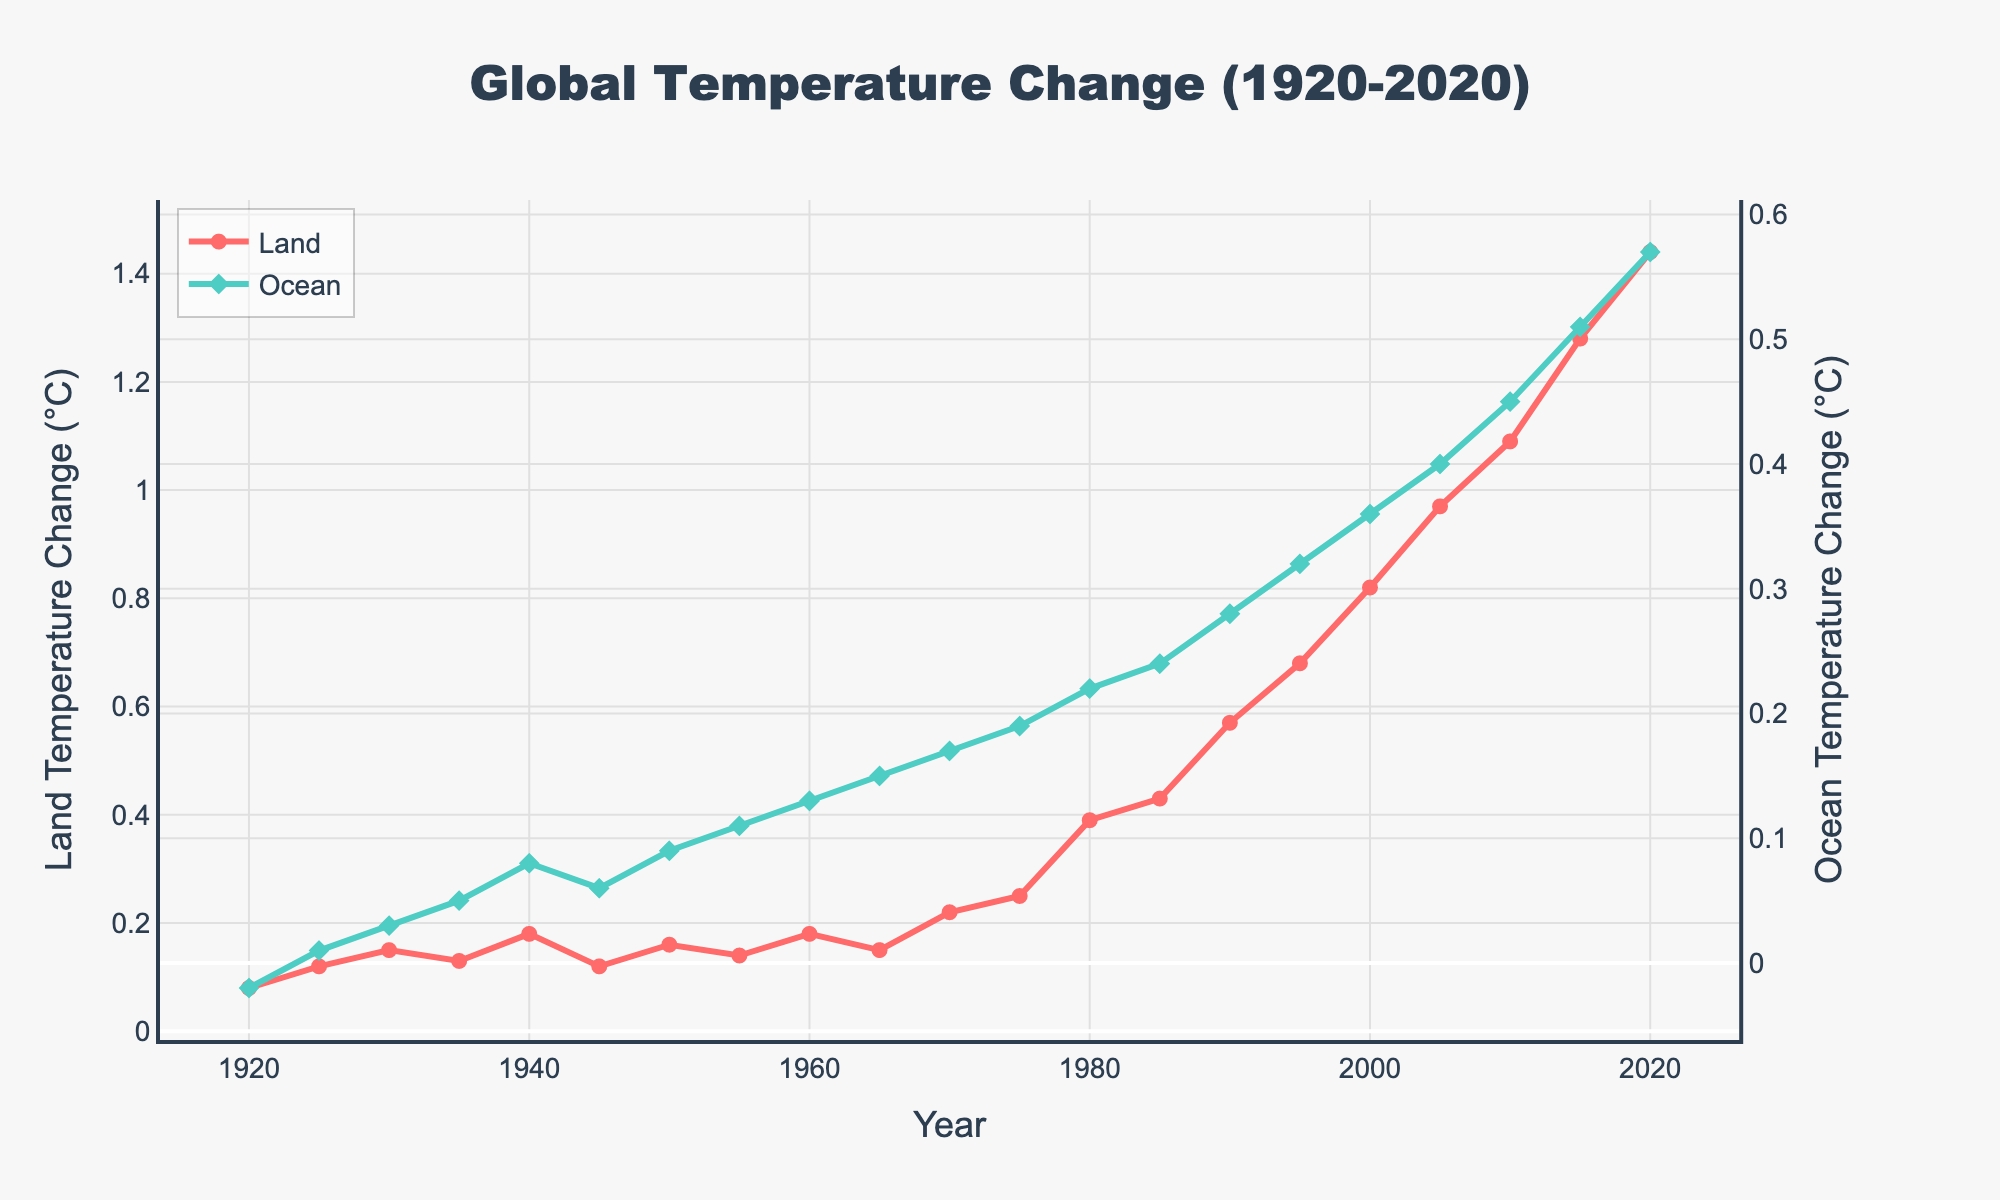What is the overall trend in land temperature change shown in the figure? The overall trend in the figure shows a clear increase in the land temperature change from 1920 to 2020. Reviewing the line graph, the land temperature change starts from 0.08°C in 1920 and reaches 1.44°C in 2020, indicating a steady rise.
Answer: Increasing How does the ocean temperature change in 1970 compare to that in 2020? The ocean temperature change in 1970 is 0.17°C, while it is 0.57°C in 2020. Comparing these values shows that the ocean temperature change has increased by 0.40°C over this period.
Answer: Increased By how much did the land temperature change between 1960 and 1980? In 1960, the land temperature change is 0.18°C, and by 1980, it is 0.39°C. The difference between these values is 0.39 - 0.18 = 0.21°C.
Answer: 0.21°C Which year shows the largest increase in land temperature change from the previous five years? To find the largest increase, we have to look at the differences for each year compared to the previous five years. From 2015 to 2020, the increase is 1.44 - 1.28 = 0.16°C, which is the largest increase recorded when comparing each five-year period.
Answer: 2020 Are there any years with a decrease in land temperature change compared to the previous year? Upon reviewing the data points on the graph, it can be observed that from 1940 (0.18°C) to 1945 (0.12°C), there was a decrease of 0.06°C.
Answer: Yes What is the difference in temperature change between land and ocean for the year 2015? In 2015, the land temperature change is 1.28°C, and the ocean temperature change is 0.51°C. The difference is calculated as 1.28 - 0.51 = 0.77°C.
Answer: 0.77°C During which decade did the land temperature change experience the most consistent increase? By examining the graph, the land temperature change from 2000 to 2010 shows a consistent increase from 0.82°C to 1.09°C and then to 1.28°C in 2015 and 1.44°C in 2020. This indicates a consistent rise during the 2000s-2010s.
Answer: 2000s-2010s How do the changes in ocean temperature compare to changes in land temperature in terms of magnitude from 1920 to 2020? To compare the magnitude, note that the land temperature change increased from 0.08°C to 1.44°C (an increase of 1.36°C), while the ocean temperature change increased from -0.02°C to 0.57°C (an increase of 0.59°C). So, the land temperature change shows a greater magnitude of increase.
Answer: Land > Ocean Which temperature change (land or ocean) shows a more significant rise during the 1970s? In 1970, the land temperature change is 0.22°C and it rises to 0.39°C in 1980, an increase of 0.17°C. For oceans, it starts at 0.17°C in 1970 and rises to 0.22°C in 1980, an increase of 0.05°C. Thus, land temperature shows a more significant rise.
Answer: Land What is the average land temperature change for the first half of the century (1920 to 1970)? Summing the land temperature changes from 1920 to 1970 and dividing by the number of these years: (0.08 + 0.12 + 0.15 + 0.13 + 0.18 + 0.12 + 0.16 + 0.14 + 0.18 + 0.15 + 0.22) / 11, yielding approximately 0.15°C.
Answer: 0.15°C 